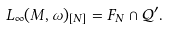Convert formula to latex. <formula><loc_0><loc_0><loc_500><loc_500>L _ { \infty } ( M , \omega ) _ { [ N ] } = F _ { N } \cap \mathcal { Q ^ { \prime } } .</formula> 